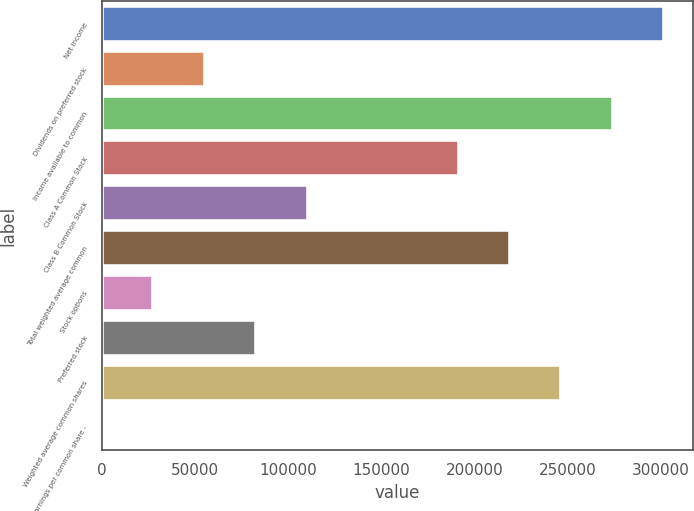Convert chart to OTSL. <chart><loc_0><loc_0><loc_500><loc_500><bar_chart><fcel>Net income<fcel>Dividends on preferred stock<fcel>Income available to common<fcel>Class A Common Stock<fcel>Class B Common Stock<fcel>Total weighted average common<fcel>Stock options<fcel>Preferred stock<fcel>Weighted average common shares<fcel>Earnings per common share -<nl><fcel>302074<fcel>55293.8<fcel>274428<fcel>191489<fcel>110586<fcel>219135<fcel>27647.5<fcel>82940<fcel>246782<fcel>1.19<nl></chart> 